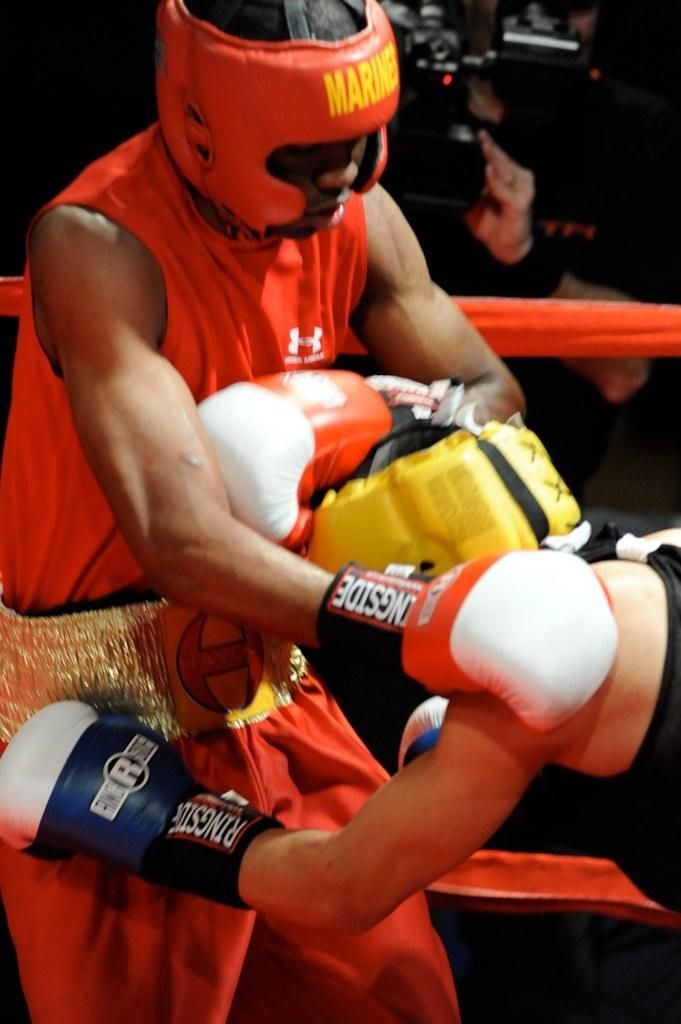How many people are in the image? There are two persons standing in the image. What are the two persons doing? The two persons are boxing. Is there anyone else in the image besides the two boxers? Yes, there is a man standing at the back in the image. What is the man at the back doing? The man is holding a camera in his hands. What type of trade is being conducted between the two boxers in the image? There is no trade being conducted between the two boxers in the image; they are engaged in a boxing match. 